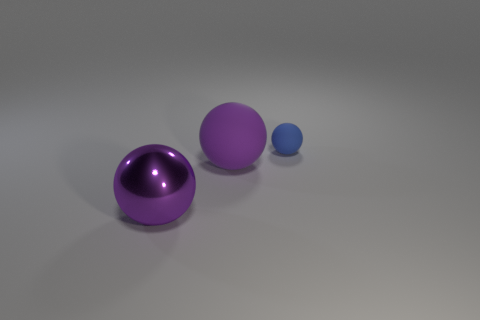There is a matte sphere that is behind the purple ball that is behind the metallic thing; what color is it?
Ensure brevity in your answer.  Blue. There is a matte sphere on the left side of the small matte thing; how big is it?
Keep it short and to the point. Large. Are there any big things that have the same material as the small ball?
Your response must be concise. Yes. How many purple rubber things have the same shape as the tiny blue matte object?
Ensure brevity in your answer.  1. What is the shape of the purple thing that is behind the large shiny ball that is in front of the big purple object that is right of the big purple shiny ball?
Offer a terse response. Sphere. The sphere that is both to the right of the large shiny thing and in front of the small ball is made of what material?
Offer a very short reply. Rubber. There is a sphere in front of the purple rubber sphere; does it have the same size as the big purple matte object?
Keep it short and to the point. Yes. Is there any other thing that has the same size as the blue sphere?
Your response must be concise. No. Are there more big purple shiny things that are behind the purple rubber object than purple metal balls that are behind the small matte thing?
Offer a very short reply. No. What color is the small matte ball that is behind the big thing in front of the rubber ball that is to the left of the small rubber sphere?
Provide a short and direct response. Blue. 